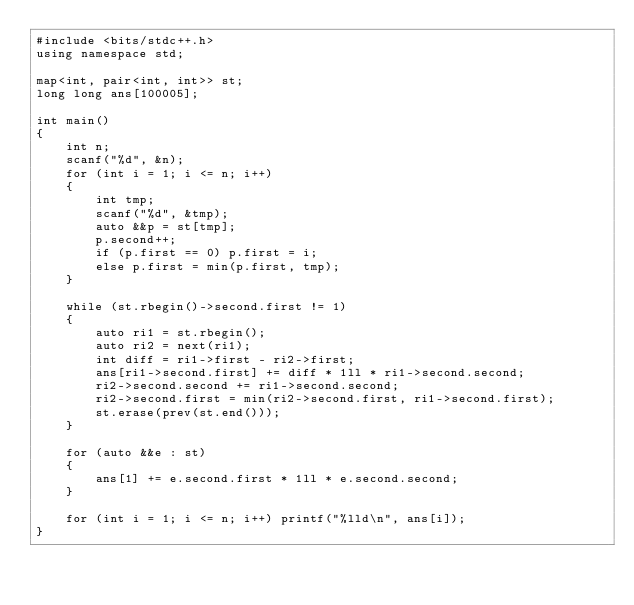<code> <loc_0><loc_0><loc_500><loc_500><_C++_>#include <bits/stdc++.h>
using namespace std;

map<int, pair<int, int>> st;
long long ans[100005];

int main()
{
	int n;
	scanf("%d", &n);
	for (int i = 1; i <= n; i++)
	{
		int tmp;
		scanf("%d", &tmp);
		auto &&p = st[tmp];
		p.second++;
		if (p.first == 0) p.first = i;
		else p.first = min(p.first, tmp);
	}

	while (st.rbegin()->second.first != 1)
	{
		auto ri1 = st.rbegin();
		auto ri2 = next(ri1);
		int diff = ri1->first - ri2->first;
		ans[ri1->second.first] += diff * 1ll * ri1->second.second;
		ri2->second.second += ri1->second.second;
		ri2->second.first = min(ri2->second.first, ri1->second.first);
		st.erase(prev(st.end()));
	}

	for (auto &&e : st)
	{
		ans[1] += e.second.first * 1ll * e.second.second;
	}

	for (int i = 1; i <= n; i++) printf("%lld\n", ans[i]);
}</code> 